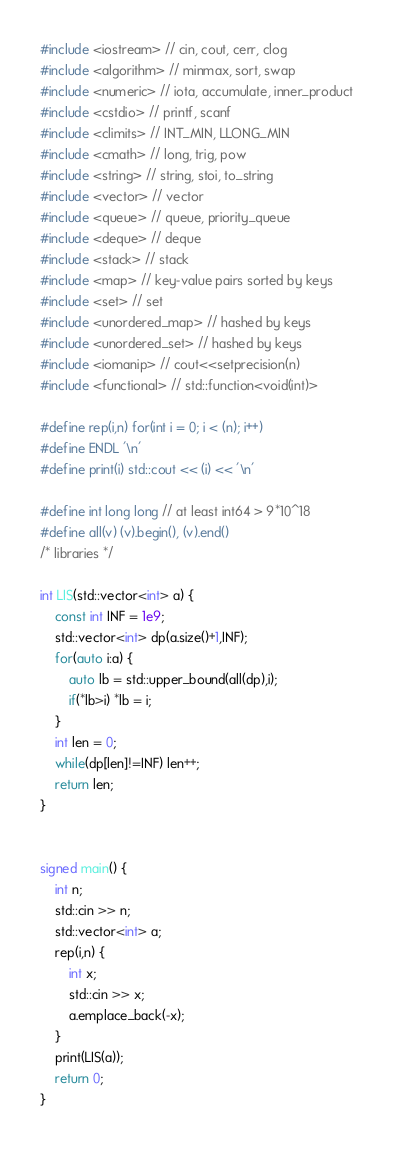Convert code to text. <code><loc_0><loc_0><loc_500><loc_500><_C++_>#include <iostream> // cin, cout, cerr, clog
#include <algorithm> // minmax, sort, swap
#include <numeric> // iota, accumulate, inner_product
#include <cstdio> // printf, scanf
#include <climits> // INT_MIN, LLONG_MIN
#include <cmath> // long, trig, pow
#include <string> // string, stoi, to_string
#include <vector> // vector
#include <queue> // queue, priority_queue
#include <deque> // deque
#include <stack> // stack
#include <map> // key-value pairs sorted by keys
#include <set> // set
#include <unordered_map> // hashed by keys
#include <unordered_set> // hashed by keys
#include <iomanip> // cout<<setprecision(n)
#include <functional> // std::function<void(int)>

#define rep(i,n) for(int i = 0; i < (n); i++)
#define ENDL '\n'
#define print(i) std::cout << (i) << '\n'

#define int long long // at least int64 > 9*10^18
#define all(v) (v).begin(), (v).end()
/* libraries */

int LIS(std::vector<int> a) {
	const int INF = 1e9;
	std::vector<int> dp(a.size()+1,INF);
	for(auto i:a) {
		auto lb = std::upper_bound(all(dp),i);
		if(*lb>i) *lb = i;
	}
	int len = 0;
	while(dp[len]!=INF) len++;
	return len;
}


signed main() {
	int n;
	std::cin >> n;
	std::vector<int> a;
	rep(i,n) {
		int x;
		std::cin >> x;
		a.emplace_back(-x);
	}
	print(LIS(a));
	return 0;
}
</code> 